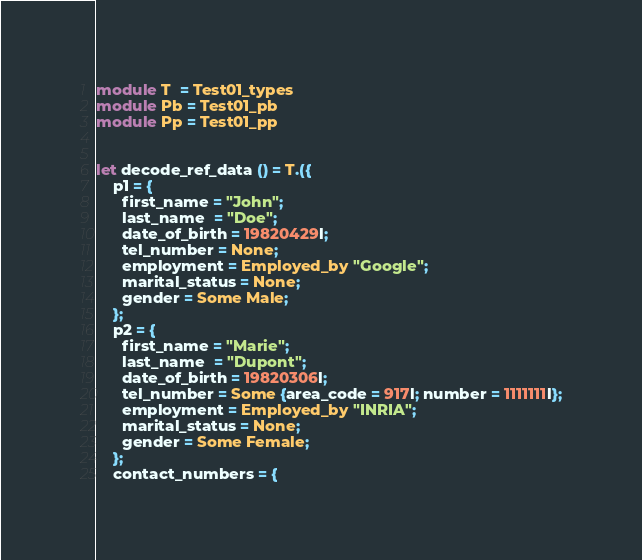<code> <loc_0><loc_0><loc_500><loc_500><_OCaml_>
module T  = Test01_types
module Pb = Test01_pb
module Pp = Test01_pp


let decode_ref_data () = T.({
    p1 = {
      first_name = "John";
      last_name  = "Doe";
      date_of_birth = 19820429l; 
      tel_number = None; 
      employment = Employed_by "Google";
      marital_status = None; 
      gender = Some Male;
    }; 
    p2 = {
      first_name = "Marie";
      last_name  = "Dupont";
      date_of_birth = 19820306l; 
      tel_number = Some {area_code = 917l; number = 1111111l};
      employment = Employed_by "INRIA";
      marital_status = None;
      gender = Some Female;
    };
    contact_numbers = {</code> 